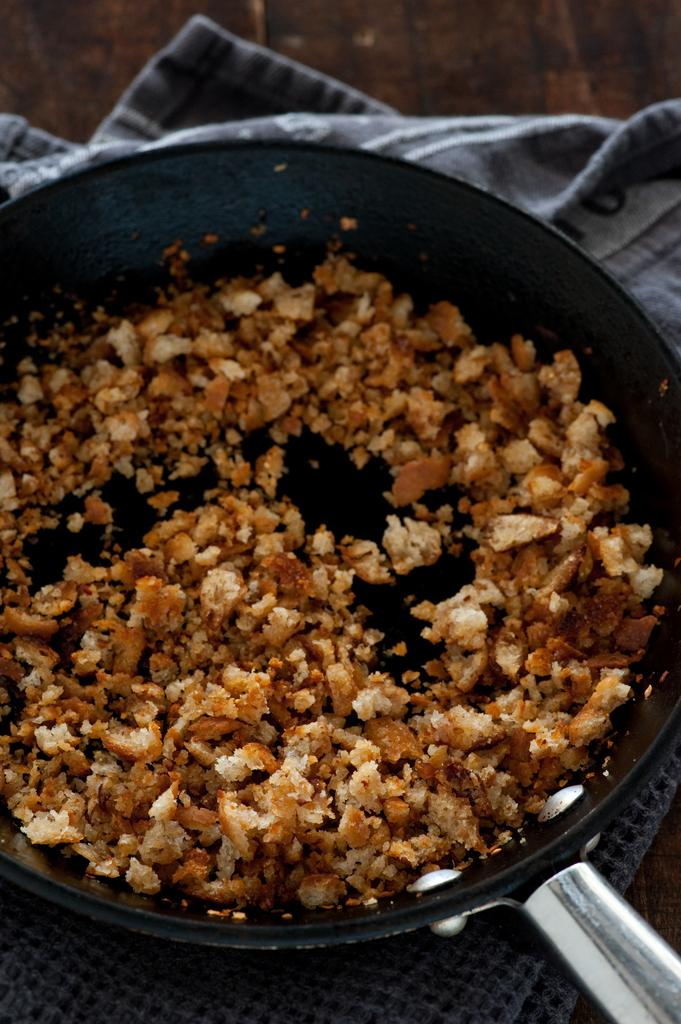What is being cooked or prepared in the pan in the image? There is a food item in a pan in the image. What else can be seen in the image besides the pan and food? There are clothes and other objects visible in the image. Can you see a ray swimming in the image? There is no ray visible in the image. What type of mountain is shown in the background of the image? There is no mountain present in the image. 